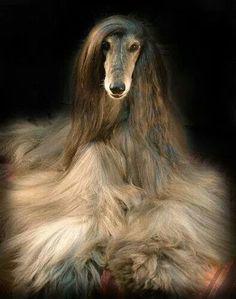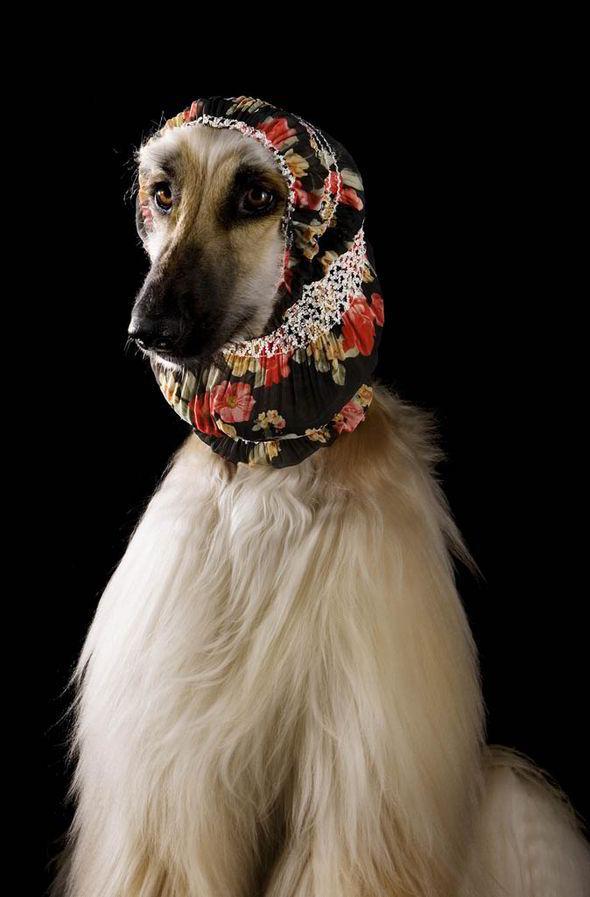The first image is the image on the left, the second image is the image on the right. For the images displayed, is the sentence "A sitting dog in one image is wearing an ornate head covering that extends down its neck." factually correct? Answer yes or no. Yes. 